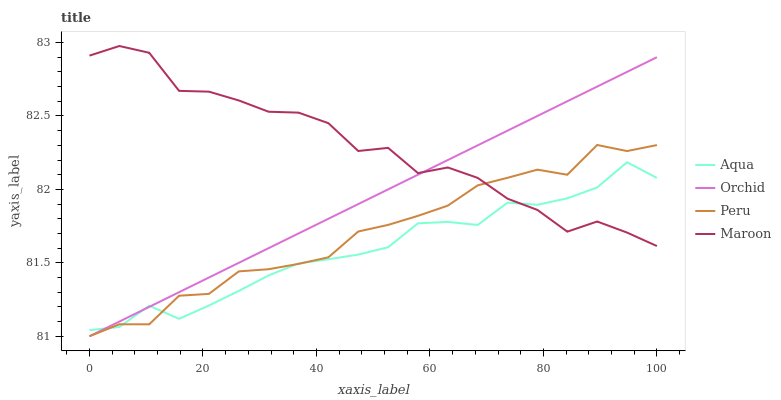Does Aqua have the minimum area under the curve?
Answer yes or no. Yes. Does Maroon have the maximum area under the curve?
Answer yes or no. Yes. Does Peru have the minimum area under the curve?
Answer yes or no. No. Does Peru have the maximum area under the curve?
Answer yes or no. No. Is Orchid the smoothest?
Answer yes or no. Yes. Is Maroon the roughest?
Answer yes or no. Yes. Is Peru the smoothest?
Answer yes or no. No. Is Peru the roughest?
Answer yes or no. No. Does Peru have the lowest value?
Answer yes or no. Yes. Does Maroon have the lowest value?
Answer yes or no. No. Does Maroon have the highest value?
Answer yes or no. Yes. Does Peru have the highest value?
Answer yes or no. No. Does Maroon intersect Aqua?
Answer yes or no. Yes. Is Maroon less than Aqua?
Answer yes or no. No. Is Maroon greater than Aqua?
Answer yes or no. No. 